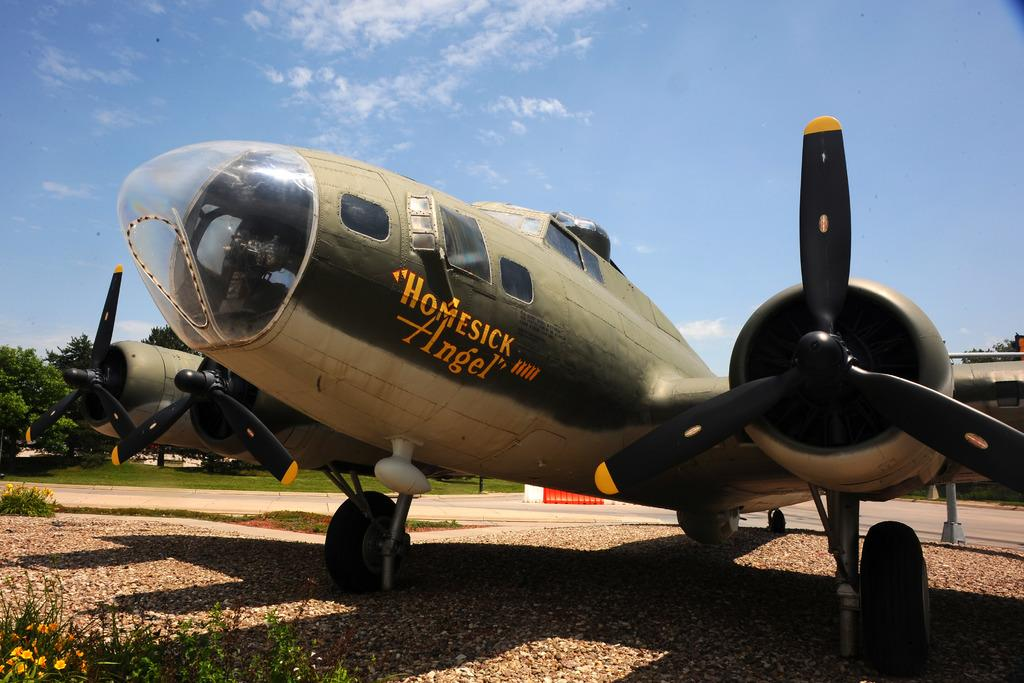<image>
Summarize the visual content of the image. A World War II plane named Homesick Angel"sits parked in a museum. 